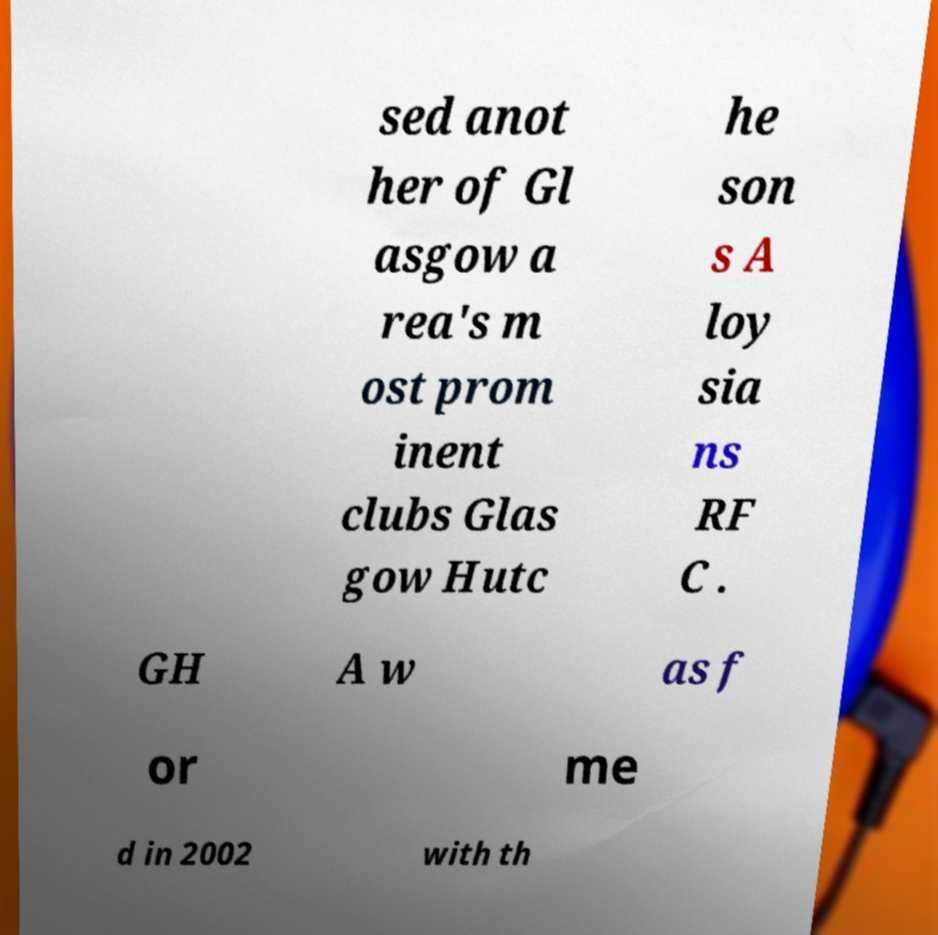Could you assist in decoding the text presented in this image and type it out clearly? sed anot her of Gl asgow a rea's m ost prom inent clubs Glas gow Hutc he son s A loy sia ns RF C . GH A w as f or me d in 2002 with th 